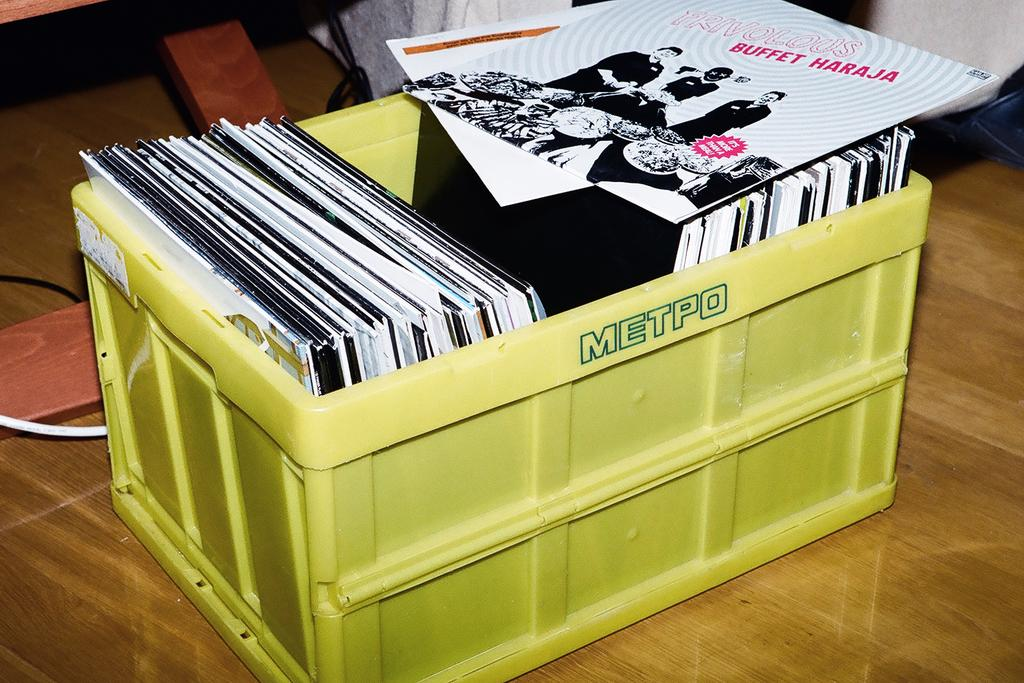<image>
Present a compact description of the photo's key features. A collection of record albums are stored in a plastic METPO box. 